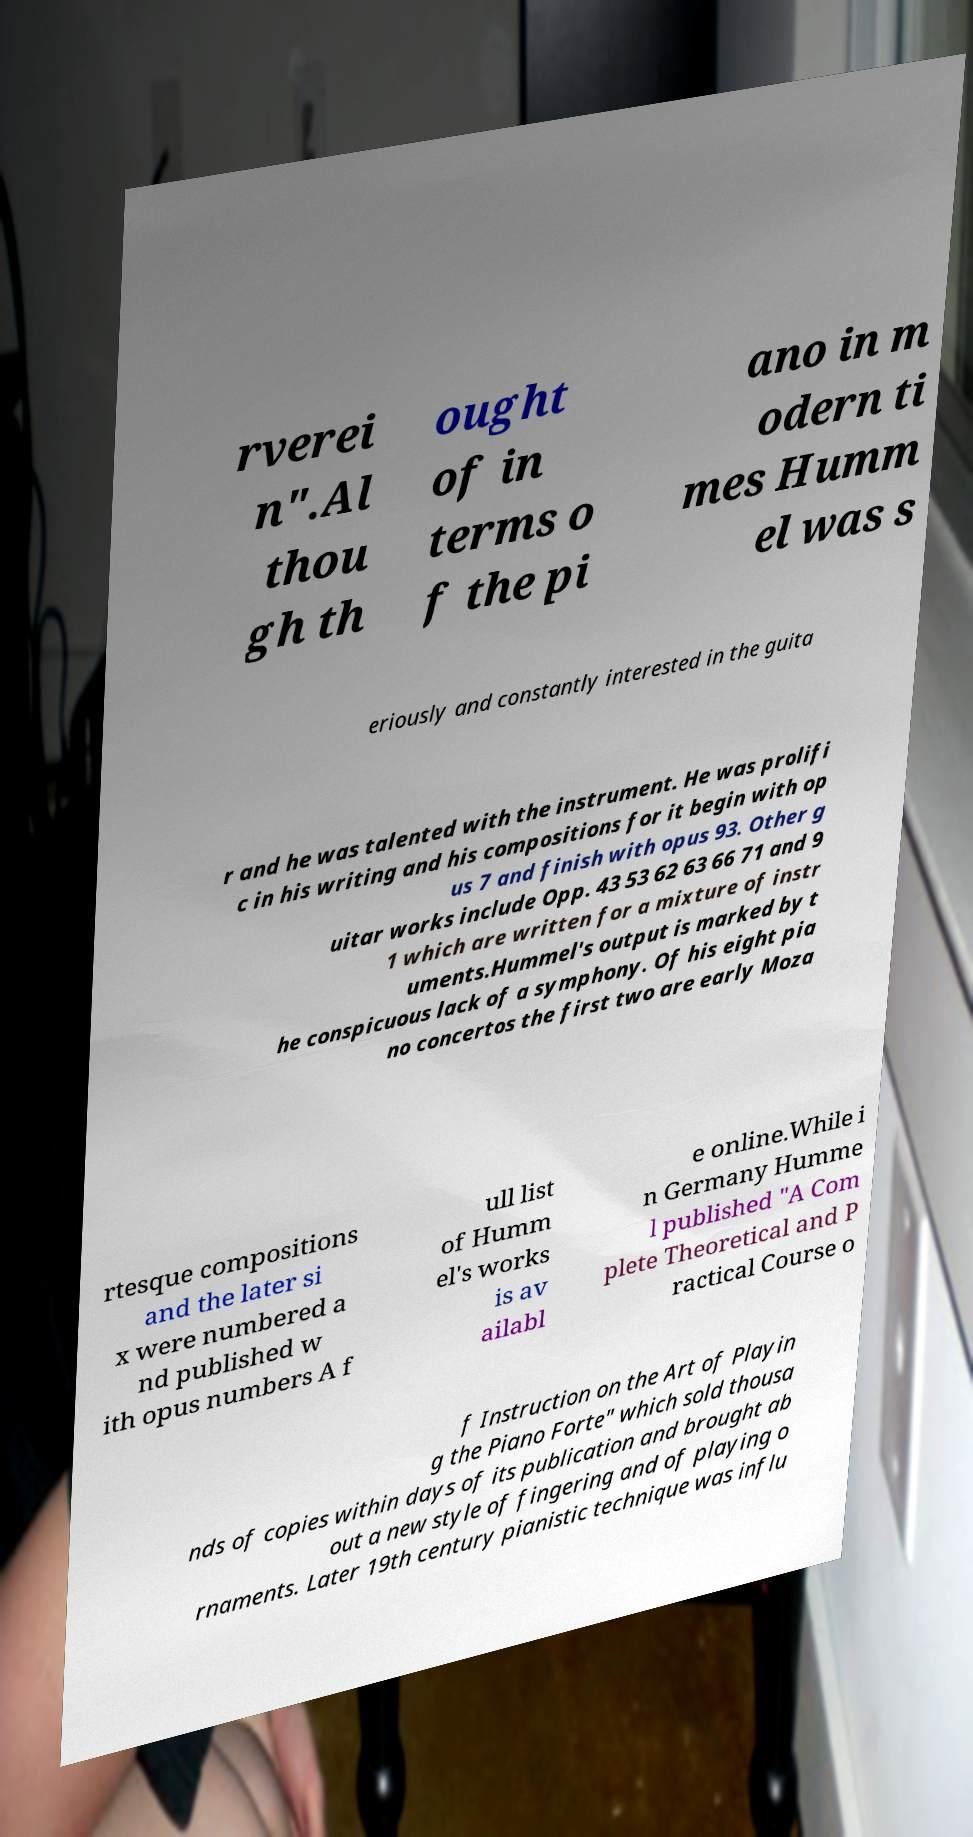Can you read and provide the text displayed in the image?This photo seems to have some interesting text. Can you extract and type it out for me? rverei n".Al thou gh th ought of in terms o f the pi ano in m odern ti mes Humm el was s eriously and constantly interested in the guita r and he was talented with the instrument. He was prolifi c in his writing and his compositions for it begin with op us 7 and finish with opus 93. Other g uitar works include Opp. 43 53 62 63 66 71 and 9 1 which are written for a mixture of instr uments.Hummel's output is marked by t he conspicuous lack of a symphony. Of his eight pia no concertos the first two are early Moza rtesque compositions and the later si x were numbered a nd published w ith opus numbers A f ull list of Humm el's works is av ailabl e online.While i n Germany Humme l published "A Com plete Theoretical and P ractical Course o f Instruction on the Art of Playin g the Piano Forte" which sold thousa nds of copies within days of its publication and brought ab out a new style of fingering and of playing o rnaments. Later 19th century pianistic technique was influ 